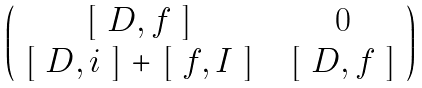<formula> <loc_0><loc_0><loc_500><loc_500>\begin{pmatrix} $ [ $ D , f $ ] $ & 0 \\ $ [ $ D , i $ ] $ + $ [ $ f , I $ ] $ & $ [ $ D , f $ ] $ \\ \end{pmatrix}</formula> 